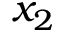Convert formula to latex. <formula><loc_0><loc_0><loc_500><loc_500>x _ { 2 }</formula> 